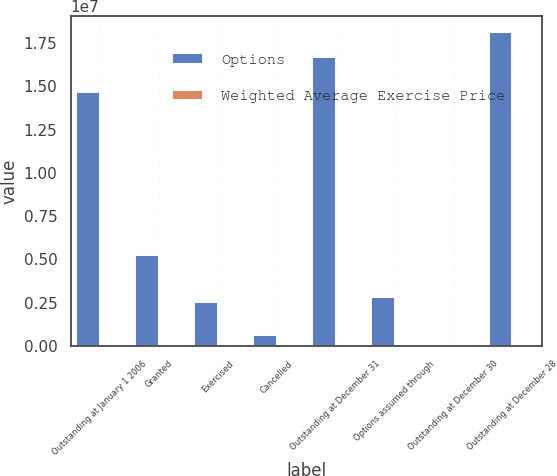<chart> <loc_0><loc_0><loc_500><loc_500><stacked_bar_chart><ecel><fcel>Outstanding at January 1 2006<fcel>Granted<fcel>Exercised<fcel>Cancelled<fcel>Outstanding at December 31<fcel>Options assumed through<fcel>Outstanding at December 30<fcel>Outstanding at December 28<nl><fcel>Options<fcel>1.46509e+07<fcel>5.2421e+06<fcel>2.54624e+06<fcel>628484<fcel>1.67182e+07<fcel>2.84866e+06<fcel>16.26<fcel>1.81342e+07<nl><fcel>Weighted Average Exercise Price<fcel>3.98<fcel>13.62<fcel>3.64<fcel>6.22<fcel>6.97<fcel>10.69<fcel>12.13<fcel>16.26<nl></chart> 